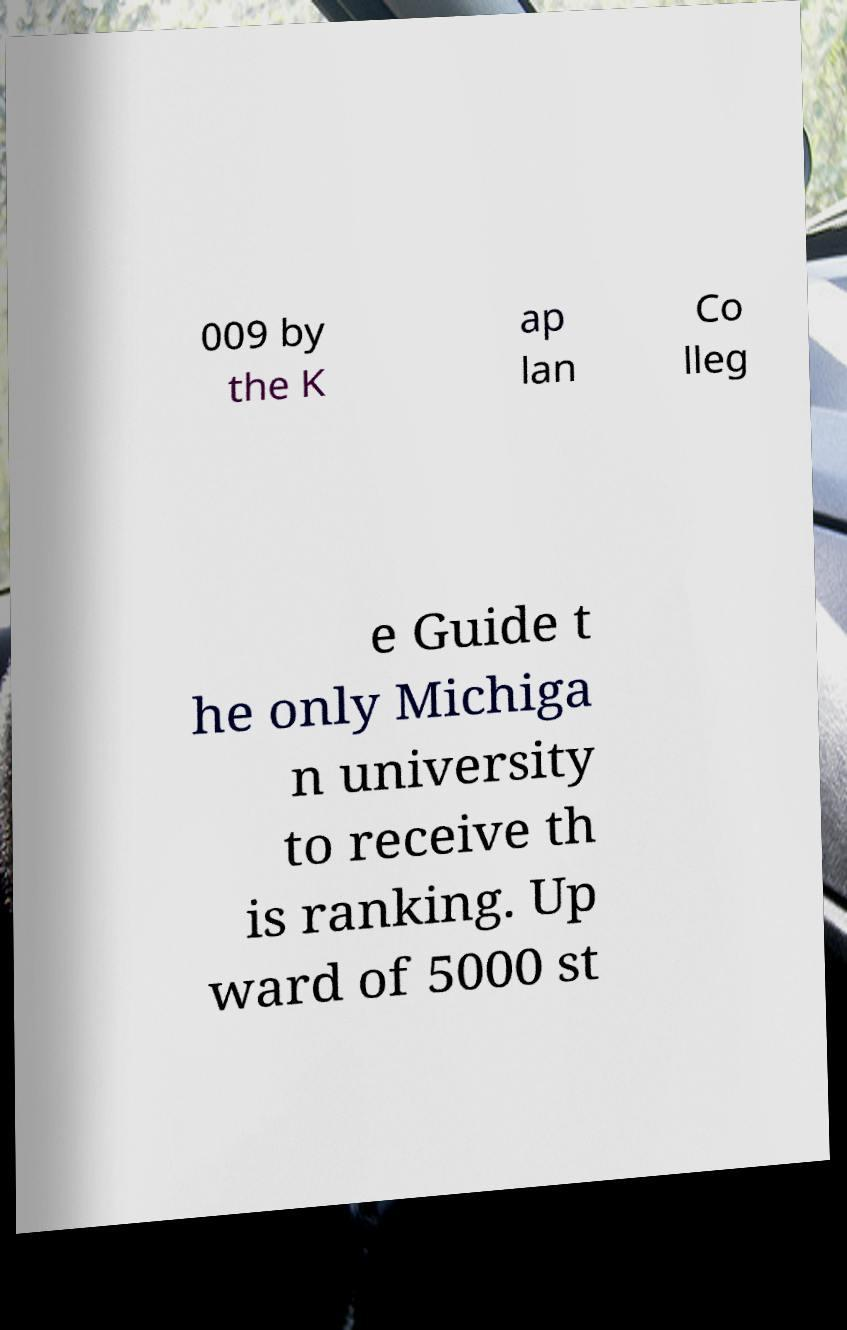I need the written content from this picture converted into text. Can you do that? 009 by the K ap lan Co lleg e Guide t he only Michiga n university to receive th is ranking. Up ward of 5000 st 